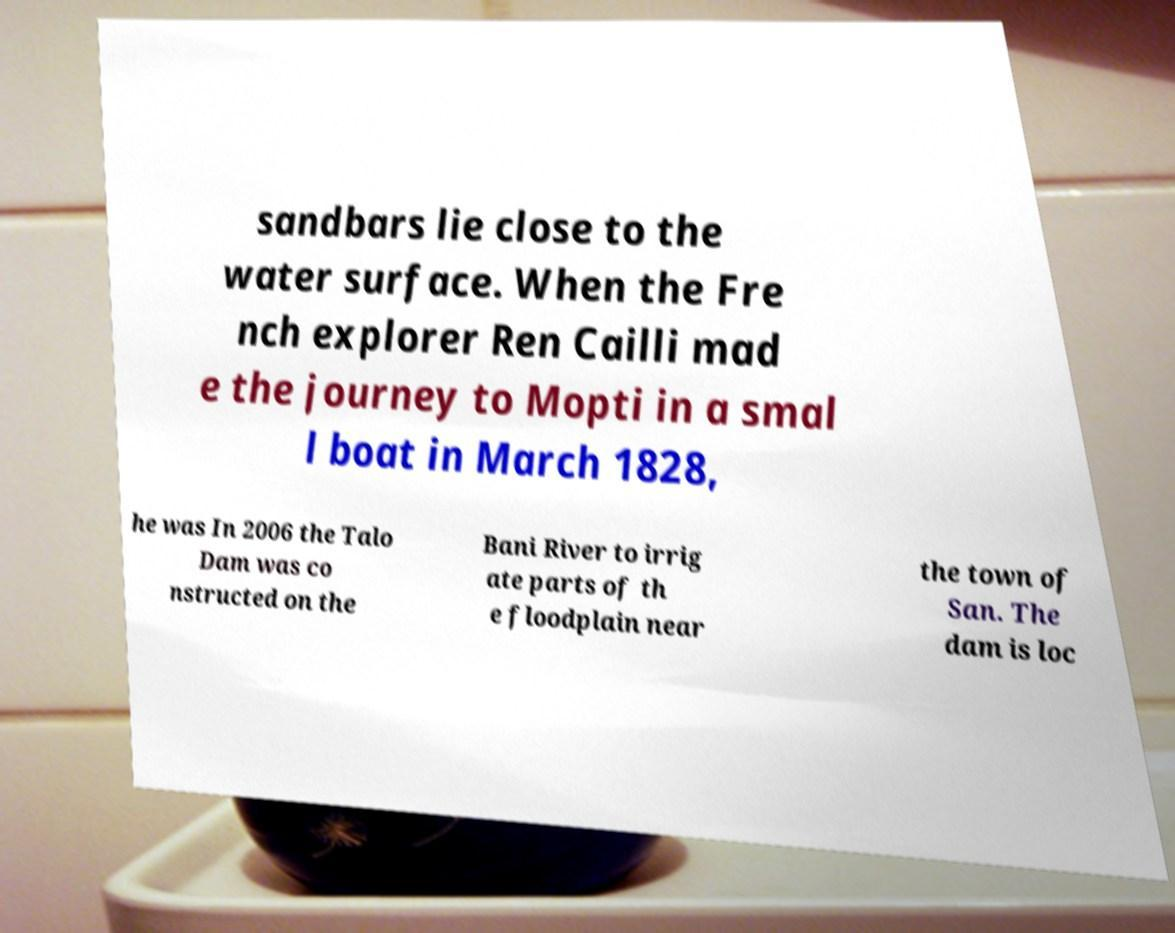There's text embedded in this image that I need extracted. Can you transcribe it verbatim? sandbars lie close to the water surface. When the Fre nch explorer Ren Cailli mad e the journey to Mopti in a smal l boat in March 1828, he was In 2006 the Talo Dam was co nstructed on the Bani River to irrig ate parts of th e floodplain near the town of San. The dam is loc 